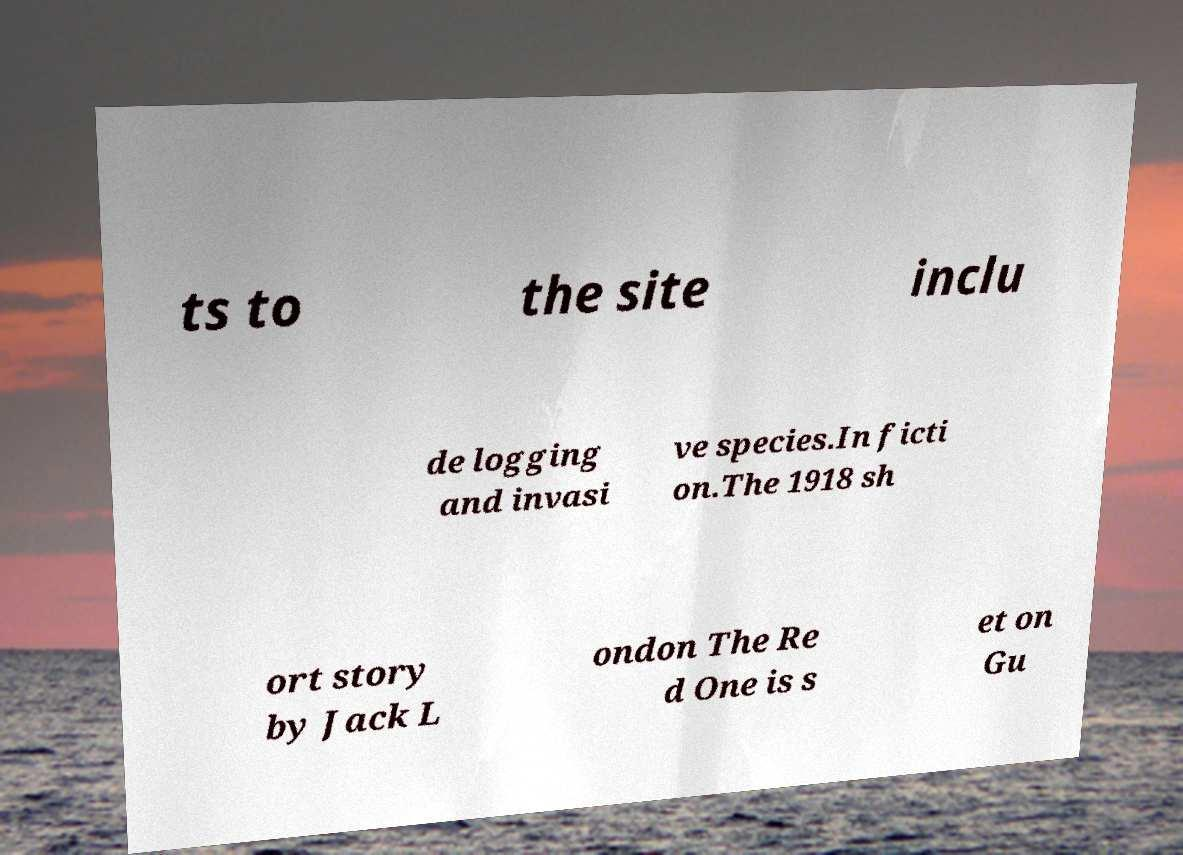Could you assist in decoding the text presented in this image and type it out clearly? ts to the site inclu de logging and invasi ve species.In ficti on.The 1918 sh ort story by Jack L ondon The Re d One is s et on Gu 